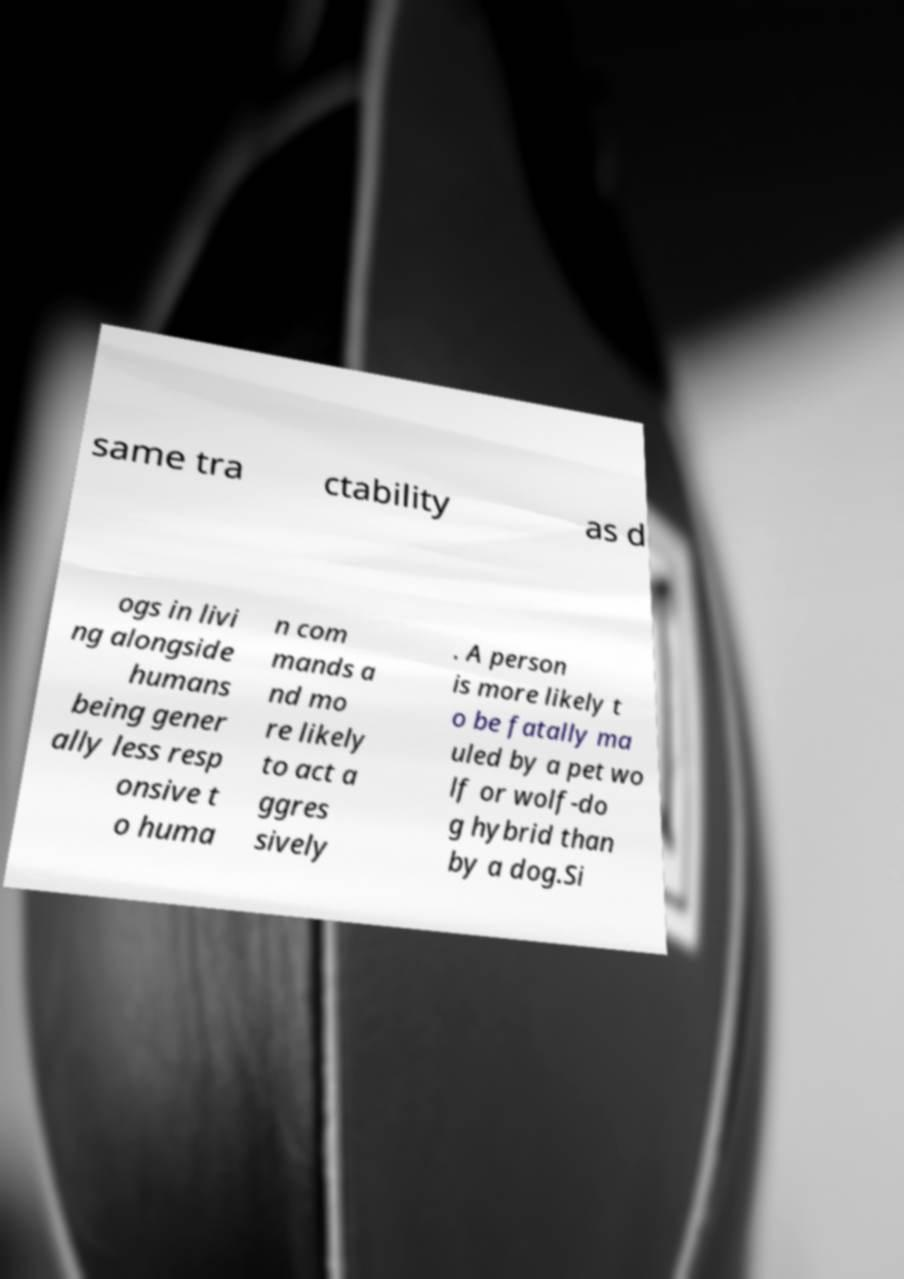Please identify and transcribe the text found in this image. same tra ctability as d ogs in livi ng alongside humans being gener ally less resp onsive t o huma n com mands a nd mo re likely to act a ggres sively . A person is more likely t o be fatally ma uled by a pet wo lf or wolf-do g hybrid than by a dog.Si 